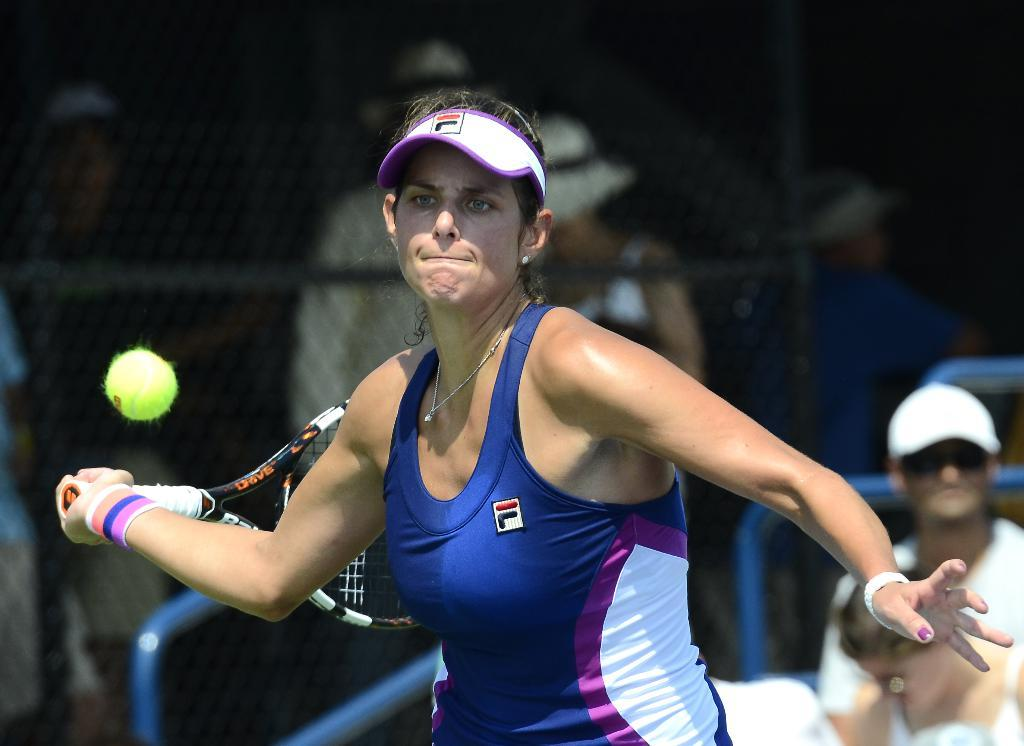Who is present in the image? There is a woman in the image. What is the woman holding in the image? The woman is holding a racket. What else can be seen in the image? There is a ball in the image. What type of plantation can be seen in the background of the image? There is no plantation visible in the image; it only features a woman holding a racket and a ball. 